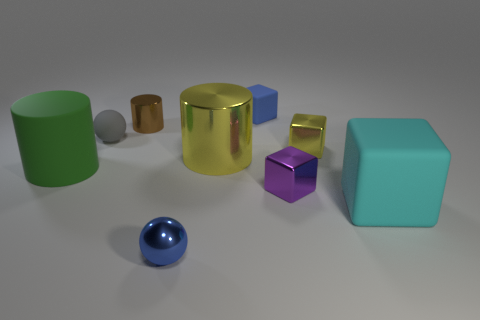Add 1 tiny purple metal blocks. How many objects exist? 10 Subtract all blocks. How many objects are left? 5 Subtract all tiny balls. Subtract all small yellow metallic cubes. How many objects are left? 6 Add 9 rubber spheres. How many rubber spheres are left? 10 Add 3 brown metal cylinders. How many brown metal cylinders exist? 4 Subtract 1 yellow cubes. How many objects are left? 8 